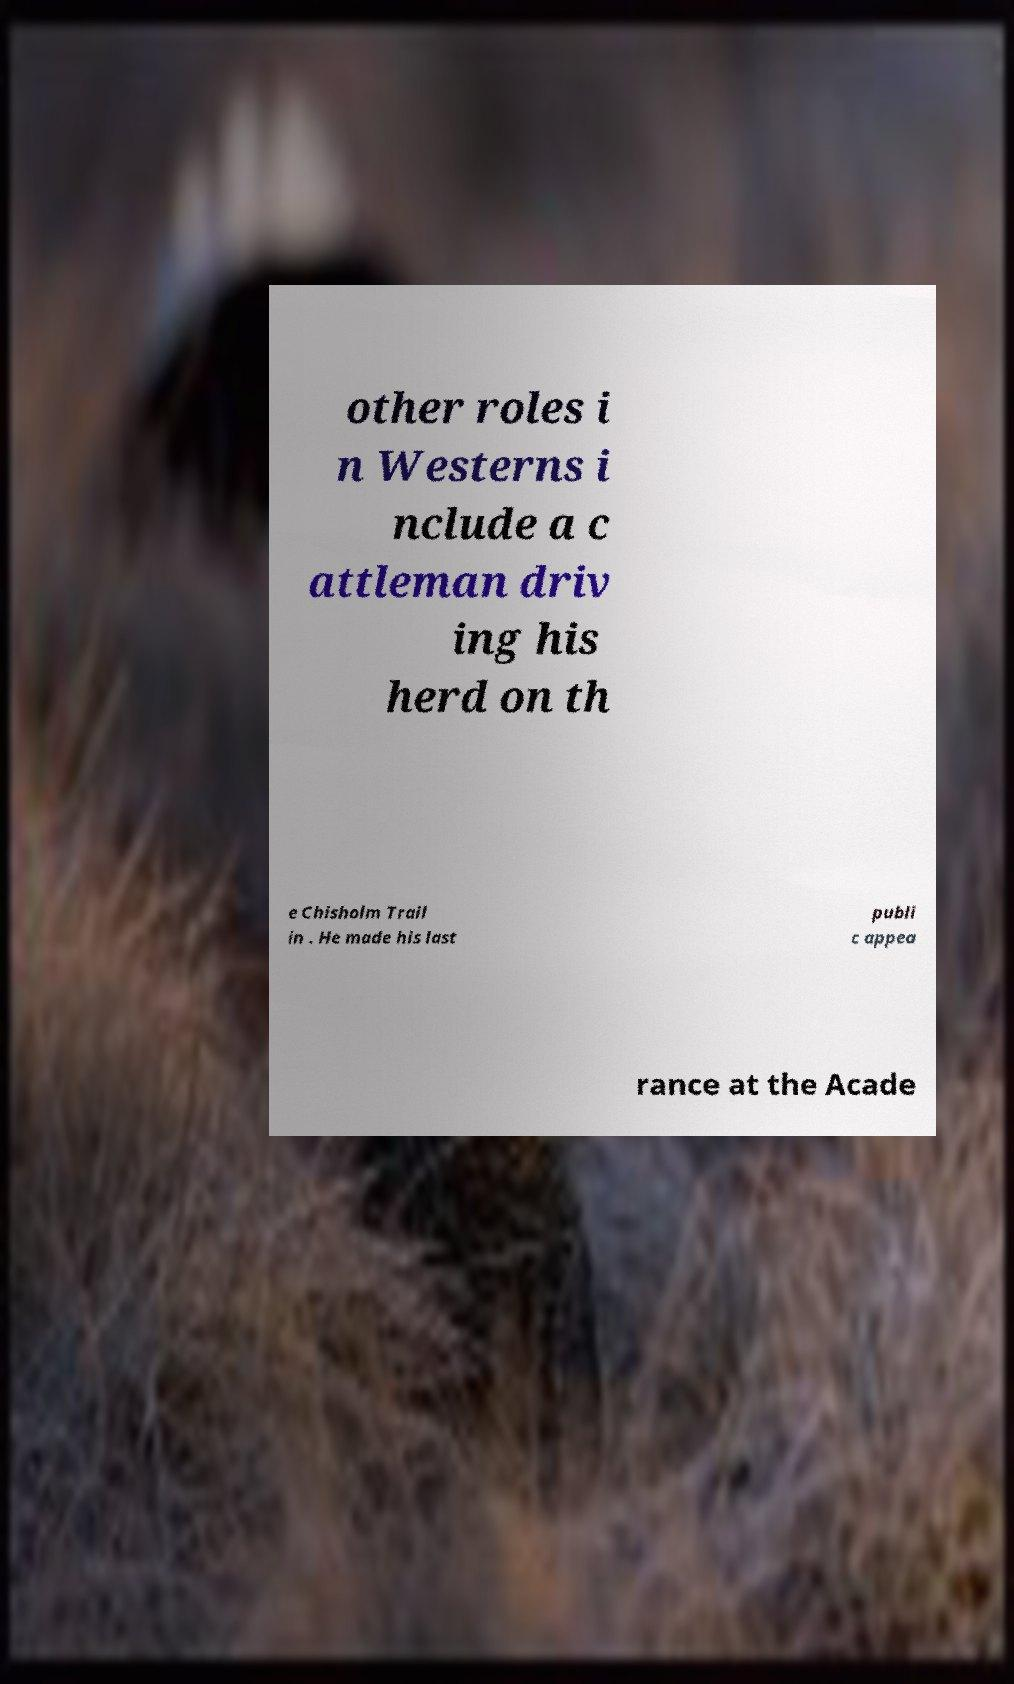Can you read and provide the text displayed in the image?This photo seems to have some interesting text. Can you extract and type it out for me? other roles i n Westerns i nclude a c attleman driv ing his herd on th e Chisholm Trail in . He made his last publi c appea rance at the Acade 